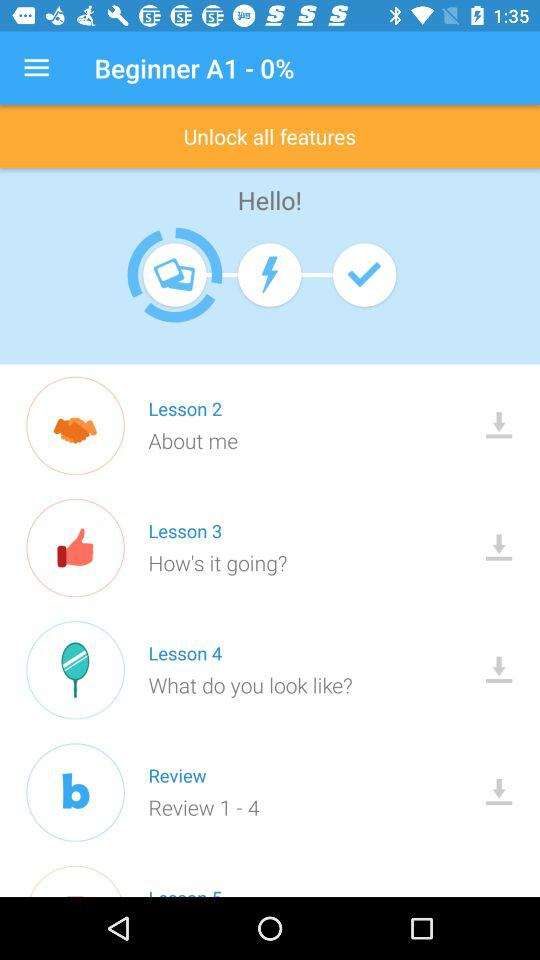How many lessons are there in total?
Answer the question using a single word or phrase. 4 